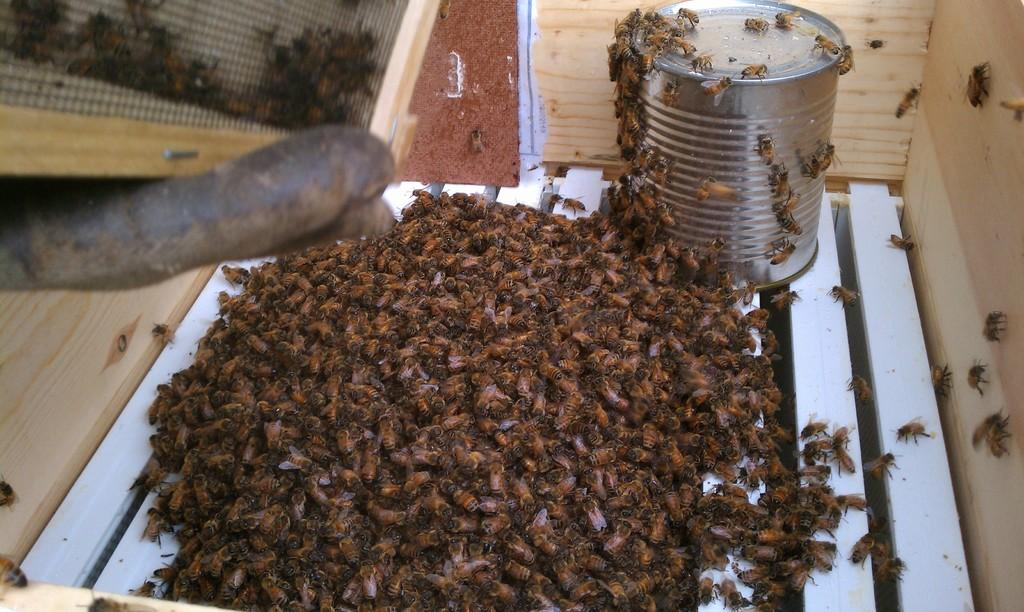What is located in the center of the image? There are honey bees in the center of the image. What type of object can be seen in the image besides the honey bees? There is a tin in the image. What type of frame is the father holding in the image? There is no frame or father present in the image; it only features honey bees and a tin. 